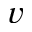Convert formula to latex. <formula><loc_0><loc_0><loc_500><loc_500>v</formula> 